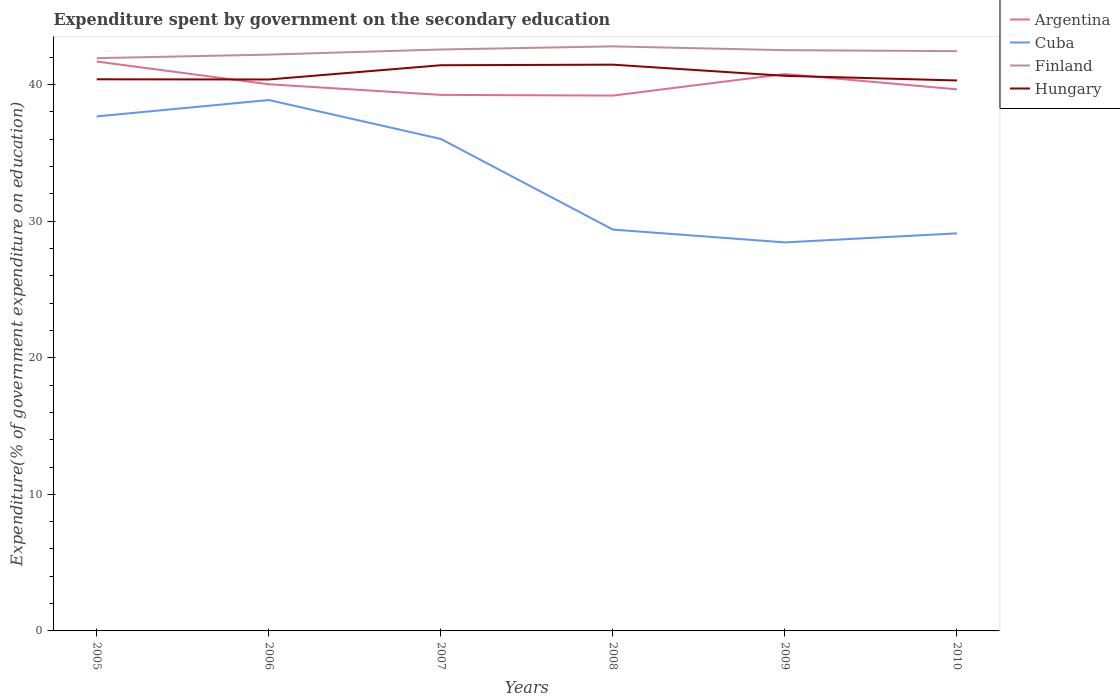Does the line corresponding to Hungary intersect with the line corresponding to Argentina?
Your answer should be very brief. Yes. Across all years, what is the maximum expenditure spent by government on the secondary education in Argentina?
Keep it short and to the point. 39.19. In which year was the expenditure spent by government on the secondary education in Cuba maximum?
Provide a short and direct response. 2009. What is the total expenditure spent by government on the secondary education in Argentina in the graph?
Keep it short and to the point. 0.78. What is the difference between the highest and the second highest expenditure spent by government on the secondary education in Finland?
Keep it short and to the point. 0.86. How many lines are there?
Your response must be concise. 4. What is the difference between two consecutive major ticks on the Y-axis?
Your response must be concise. 10. Where does the legend appear in the graph?
Offer a very short reply. Top right. How are the legend labels stacked?
Offer a terse response. Vertical. What is the title of the graph?
Your answer should be very brief. Expenditure spent by government on the secondary education. Does "Eritrea" appear as one of the legend labels in the graph?
Your answer should be very brief. No. What is the label or title of the X-axis?
Your answer should be compact. Years. What is the label or title of the Y-axis?
Ensure brevity in your answer.  Expenditure(% of government expenditure on education). What is the Expenditure(% of government expenditure on education) in Argentina in 2005?
Your response must be concise. 41.69. What is the Expenditure(% of government expenditure on education) in Cuba in 2005?
Make the answer very short. 37.67. What is the Expenditure(% of government expenditure on education) in Finland in 2005?
Ensure brevity in your answer.  41.93. What is the Expenditure(% of government expenditure on education) in Hungary in 2005?
Provide a succinct answer. 40.39. What is the Expenditure(% of government expenditure on education) of Argentina in 2006?
Your response must be concise. 40.02. What is the Expenditure(% of government expenditure on education) in Cuba in 2006?
Provide a succinct answer. 38.87. What is the Expenditure(% of government expenditure on education) in Finland in 2006?
Offer a very short reply. 42.19. What is the Expenditure(% of government expenditure on education) in Hungary in 2006?
Give a very brief answer. 40.37. What is the Expenditure(% of government expenditure on education) of Argentina in 2007?
Your response must be concise. 39.25. What is the Expenditure(% of government expenditure on education) of Cuba in 2007?
Provide a short and direct response. 36.02. What is the Expenditure(% of government expenditure on education) of Finland in 2007?
Keep it short and to the point. 42.57. What is the Expenditure(% of government expenditure on education) of Hungary in 2007?
Provide a succinct answer. 41.42. What is the Expenditure(% of government expenditure on education) of Argentina in 2008?
Make the answer very short. 39.19. What is the Expenditure(% of government expenditure on education) of Cuba in 2008?
Your answer should be compact. 29.38. What is the Expenditure(% of government expenditure on education) in Finland in 2008?
Your response must be concise. 42.8. What is the Expenditure(% of government expenditure on education) of Hungary in 2008?
Give a very brief answer. 41.46. What is the Expenditure(% of government expenditure on education) in Argentina in 2009?
Ensure brevity in your answer.  40.77. What is the Expenditure(% of government expenditure on education) in Cuba in 2009?
Offer a terse response. 28.44. What is the Expenditure(% of government expenditure on education) of Finland in 2009?
Offer a very short reply. 42.52. What is the Expenditure(% of government expenditure on education) of Hungary in 2009?
Your response must be concise. 40.64. What is the Expenditure(% of government expenditure on education) of Argentina in 2010?
Give a very brief answer. 39.65. What is the Expenditure(% of government expenditure on education) in Cuba in 2010?
Your answer should be very brief. 29.11. What is the Expenditure(% of government expenditure on education) of Finland in 2010?
Keep it short and to the point. 42.45. What is the Expenditure(% of government expenditure on education) in Hungary in 2010?
Offer a very short reply. 40.3. Across all years, what is the maximum Expenditure(% of government expenditure on education) of Argentina?
Your response must be concise. 41.69. Across all years, what is the maximum Expenditure(% of government expenditure on education) of Cuba?
Make the answer very short. 38.87. Across all years, what is the maximum Expenditure(% of government expenditure on education) of Finland?
Provide a short and direct response. 42.8. Across all years, what is the maximum Expenditure(% of government expenditure on education) in Hungary?
Give a very brief answer. 41.46. Across all years, what is the minimum Expenditure(% of government expenditure on education) of Argentina?
Offer a very short reply. 39.19. Across all years, what is the minimum Expenditure(% of government expenditure on education) in Cuba?
Provide a succinct answer. 28.44. Across all years, what is the minimum Expenditure(% of government expenditure on education) in Finland?
Make the answer very short. 41.93. Across all years, what is the minimum Expenditure(% of government expenditure on education) of Hungary?
Ensure brevity in your answer.  40.3. What is the total Expenditure(% of government expenditure on education) in Argentina in the graph?
Give a very brief answer. 240.57. What is the total Expenditure(% of government expenditure on education) of Cuba in the graph?
Provide a short and direct response. 199.49. What is the total Expenditure(% of government expenditure on education) of Finland in the graph?
Give a very brief answer. 254.46. What is the total Expenditure(% of government expenditure on education) of Hungary in the graph?
Make the answer very short. 244.57. What is the difference between the Expenditure(% of government expenditure on education) of Argentina in 2005 and that in 2006?
Ensure brevity in your answer.  1.67. What is the difference between the Expenditure(% of government expenditure on education) of Finland in 2005 and that in 2006?
Offer a terse response. -0.26. What is the difference between the Expenditure(% of government expenditure on education) in Hungary in 2005 and that in 2006?
Give a very brief answer. 0.01. What is the difference between the Expenditure(% of government expenditure on education) in Argentina in 2005 and that in 2007?
Offer a very short reply. 2.44. What is the difference between the Expenditure(% of government expenditure on education) of Cuba in 2005 and that in 2007?
Ensure brevity in your answer.  1.65. What is the difference between the Expenditure(% of government expenditure on education) in Finland in 2005 and that in 2007?
Give a very brief answer. -0.63. What is the difference between the Expenditure(% of government expenditure on education) in Hungary in 2005 and that in 2007?
Make the answer very short. -1.03. What is the difference between the Expenditure(% of government expenditure on education) of Argentina in 2005 and that in 2008?
Offer a terse response. 2.49. What is the difference between the Expenditure(% of government expenditure on education) of Cuba in 2005 and that in 2008?
Ensure brevity in your answer.  8.28. What is the difference between the Expenditure(% of government expenditure on education) of Finland in 2005 and that in 2008?
Your response must be concise. -0.86. What is the difference between the Expenditure(% of government expenditure on education) in Hungary in 2005 and that in 2008?
Keep it short and to the point. -1.07. What is the difference between the Expenditure(% of government expenditure on education) of Argentina in 2005 and that in 2009?
Provide a short and direct response. 0.91. What is the difference between the Expenditure(% of government expenditure on education) in Cuba in 2005 and that in 2009?
Make the answer very short. 9.22. What is the difference between the Expenditure(% of government expenditure on education) in Finland in 2005 and that in 2009?
Provide a succinct answer. -0.58. What is the difference between the Expenditure(% of government expenditure on education) of Hungary in 2005 and that in 2009?
Keep it short and to the point. -0.25. What is the difference between the Expenditure(% of government expenditure on education) in Argentina in 2005 and that in 2010?
Your answer should be very brief. 2.04. What is the difference between the Expenditure(% of government expenditure on education) of Cuba in 2005 and that in 2010?
Offer a terse response. 8.56. What is the difference between the Expenditure(% of government expenditure on education) in Finland in 2005 and that in 2010?
Keep it short and to the point. -0.51. What is the difference between the Expenditure(% of government expenditure on education) in Hungary in 2005 and that in 2010?
Ensure brevity in your answer.  0.09. What is the difference between the Expenditure(% of government expenditure on education) in Argentina in 2006 and that in 2007?
Give a very brief answer. 0.78. What is the difference between the Expenditure(% of government expenditure on education) of Cuba in 2006 and that in 2007?
Offer a very short reply. 2.85. What is the difference between the Expenditure(% of government expenditure on education) in Finland in 2006 and that in 2007?
Your response must be concise. -0.38. What is the difference between the Expenditure(% of government expenditure on education) in Hungary in 2006 and that in 2007?
Your answer should be very brief. -1.04. What is the difference between the Expenditure(% of government expenditure on education) in Argentina in 2006 and that in 2008?
Ensure brevity in your answer.  0.83. What is the difference between the Expenditure(% of government expenditure on education) in Cuba in 2006 and that in 2008?
Provide a short and direct response. 9.48. What is the difference between the Expenditure(% of government expenditure on education) in Finland in 2006 and that in 2008?
Ensure brevity in your answer.  -0.6. What is the difference between the Expenditure(% of government expenditure on education) of Hungary in 2006 and that in 2008?
Ensure brevity in your answer.  -1.08. What is the difference between the Expenditure(% of government expenditure on education) of Argentina in 2006 and that in 2009?
Give a very brief answer. -0.75. What is the difference between the Expenditure(% of government expenditure on education) of Cuba in 2006 and that in 2009?
Provide a succinct answer. 10.42. What is the difference between the Expenditure(% of government expenditure on education) of Finland in 2006 and that in 2009?
Your answer should be very brief. -0.32. What is the difference between the Expenditure(% of government expenditure on education) of Hungary in 2006 and that in 2009?
Keep it short and to the point. -0.27. What is the difference between the Expenditure(% of government expenditure on education) of Argentina in 2006 and that in 2010?
Offer a very short reply. 0.37. What is the difference between the Expenditure(% of government expenditure on education) in Cuba in 2006 and that in 2010?
Make the answer very short. 9.76. What is the difference between the Expenditure(% of government expenditure on education) of Finland in 2006 and that in 2010?
Your answer should be compact. -0.25. What is the difference between the Expenditure(% of government expenditure on education) of Hungary in 2006 and that in 2010?
Your response must be concise. 0.07. What is the difference between the Expenditure(% of government expenditure on education) in Argentina in 2007 and that in 2008?
Give a very brief answer. 0.05. What is the difference between the Expenditure(% of government expenditure on education) of Cuba in 2007 and that in 2008?
Provide a short and direct response. 6.64. What is the difference between the Expenditure(% of government expenditure on education) in Finland in 2007 and that in 2008?
Make the answer very short. -0.23. What is the difference between the Expenditure(% of government expenditure on education) of Hungary in 2007 and that in 2008?
Make the answer very short. -0.04. What is the difference between the Expenditure(% of government expenditure on education) of Argentina in 2007 and that in 2009?
Provide a succinct answer. -1.53. What is the difference between the Expenditure(% of government expenditure on education) of Cuba in 2007 and that in 2009?
Keep it short and to the point. 7.57. What is the difference between the Expenditure(% of government expenditure on education) in Finland in 2007 and that in 2009?
Give a very brief answer. 0.05. What is the difference between the Expenditure(% of government expenditure on education) in Hungary in 2007 and that in 2009?
Your answer should be compact. 0.78. What is the difference between the Expenditure(% of government expenditure on education) in Argentina in 2007 and that in 2010?
Give a very brief answer. -0.4. What is the difference between the Expenditure(% of government expenditure on education) of Cuba in 2007 and that in 2010?
Make the answer very short. 6.91. What is the difference between the Expenditure(% of government expenditure on education) of Finland in 2007 and that in 2010?
Offer a terse response. 0.12. What is the difference between the Expenditure(% of government expenditure on education) in Hungary in 2007 and that in 2010?
Give a very brief answer. 1.11. What is the difference between the Expenditure(% of government expenditure on education) of Argentina in 2008 and that in 2009?
Offer a terse response. -1.58. What is the difference between the Expenditure(% of government expenditure on education) in Cuba in 2008 and that in 2009?
Your response must be concise. 0.94. What is the difference between the Expenditure(% of government expenditure on education) in Finland in 2008 and that in 2009?
Give a very brief answer. 0.28. What is the difference between the Expenditure(% of government expenditure on education) in Hungary in 2008 and that in 2009?
Your answer should be very brief. 0.82. What is the difference between the Expenditure(% of government expenditure on education) of Argentina in 2008 and that in 2010?
Provide a succinct answer. -0.46. What is the difference between the Expenditure(% of government expenditure on education) in Cuba in 2008 and that in 2010?
Offer a terse response. 0.28. What is the difference between the Expenditure(% of government expenditure on education) in Finland in 2008 and that in 2010?
Give a very brief answer. 0.35. What is the difference between the Expenditure(% of government expenditure on education) of Hungary in 2008 and that in 2010?
Provide a succinct answer. 1.16. What is the difference between the Expenditure(% of government expenditure on education) in Argentina in 2009 and that in 2010?
Provide a short and direct response. 1.12. What is the difference between the Expenditure(% of government expenditure on education) of Cuba in 2009 and that in 2010?
Your response must be concise. -0.66. What is the difference between the Expenditure(% of government expenditure on education) in Finland in 2009 and that in 2010?
Your answer should be very brief. 0.07. What is the difference between the Expenditure(% of government expenditure on education) of Hungary in 2009 and that in 2010?
Give a very brief answer. 0.34. What is the difference between the Expenditure(% of government expenditure on education) of Argentina in 2005 and the Expenditure(% of government expenditure on education) of Cuba in 2006?
Provide a short and direct response. 2.82. What is the difference between the Expenditure(% of government expenditure on education) in Argentina in 2005 and the Expenditure(% of government expenditure on education) in Finland in 2006?
Offer a terse response. -0.51. What is the difference between the Expenditure(% of government expenditure on education) of Argentina in 2005 and the Expenditure(% of government expenditure on education) of Hungary in 2006?
Offer a terse response. 1.31. What is the difference between the Expenditure(% of government expenditure on education) in Cuba in 2005 and the Expenditure(% of government expenditure on education) in Finland in 2006?
Make the answer very short. -4.53. What is the difference between the Expenditure(% of government expenditure on education) in Cuba in 2005 and the Expenditure(% of government expenditure on education) in Hungary in 2006?
Ensure brevity in your answer.  -2.7. What is the difference between the Expenditure(% of government expenditure on education) of Finland in 2005 and the Expenditure(% of government expenditure on education) of Hungary in 2006?
Your answer should be compact. 1.56. What is the difference between the Expenditure(% of government expenditure on education) of Argentina in 2005 and the Expenditure(% of government expenditure on education) of Cuba in 2007?
Your answer should be very brief. 5.67. What is the difference between the Expenditure(% of government expenditure on education) in Argentina in 2005 and the Expenditure(% of government expenditure on education) in Finland in 2007?
Make the answer very short. -0.88. What is the difference between the Expenditure(% of government expenditure on education) in Argentina in 2005 and the Expenditure(% of government expenditure on education) in Hungary in 2007?
Your answer should be compact. 0.27. What is the difference between the Expenditure(% of government expenditure on education) in Cuba in 2005 and the Expenditure(% of government expenditure on education) in Finland in 2007?
Your answer should be compact. -4.9. What is the difference between the Expenditure(% of government expenditure on education) in Cuba in 2005 and the Expenditure(% of government expenditure on education) in Hungary in 2007?
Ensure brevity in your answer.  -3.75. What is the difference between the Expenditure(% of government expenditure on education) in Finland in 2005 and the Expenditure(% of government expenditure on education) in Hungary in 2007?
Make the answer very short. 0.52. What is the difference between the Expenditure(% of government expenditure on education) in Argentina in 2005 and the Expenditure(% of government expenditure on education) in Cuba in 2008?
Your answer should be compact. 12.3. What is the difference between the Expenditure(% of government expenditure on education) in Argentina in 2005 and the Expenditure(% of government expenditure on education) in Finland in 2008?
Make the answer very short. -1.11. What is the difference between the Expenditure(% of government expenditure on education) of Argentina in 2005 and the Expenditure(% of government expenditure on education) of Hungary in 2008?
Keep it short and to the point. 0.23. What is the difference between the Expenditure(% of government expenditure on education) of Cuba in 2005 and the Expenditure(% of government expenditure on education) of Finland in 2008?
Offer a very short reply. -5.13. What is the difference between the Expenditure(% of government expenditure on education) of Cuba in 2005 and the Expenditure(% of government expenditure on education) of Hungary in 2008?
Offer a terse response. -3.79. What is the difference between the Expenditure(% of government expenditure on education) of Finland in 2005 and the Expenditure(% of government expenditure on education) of Hungary in 2008?
Your answer should be very brief. 0.48. What is the difference between the Expenditure(% of government expenditure on education) of Argentina in 2005 and the Expenditure(% of government expenditure on education) of Cuba in 2009?
Provide a succinct answer. 13.24. What is the difference between the Expenditure(% of government expenditure on education) of Argentina in 2005 and the Expenditure(% of government expenditure on education) of Finland in 2009?
Keep it short and to the point. -0.83. What is the difference between the Expenditure(% of government expenditure on education) in Argentina in 2005 and the Expenditure(% of government expenditure on education) in Hungary in 2009?
Your answer should be very brief. 1.05. What is the difference between the Expenditure(% of government expenditure on education) of Cuba in 2005 and the Expenditure(% of government expenditure on education) of Finland in 2009?
Ensure brevity in your answer.  -4.85. What is the difference between the Expenditure(% of government expenditure on education) of Cuba in 2005 and the Expenditure(% of government expenditure on education) of Hungary in 2009?
Make the answer very short. -2.97. What is the difference between the Expenditure(% of government expenditure on education) of Finland in 2005 and the Expenditure(% of government expenditure on education) of Hungary in 2009?
Offer a terse response. 1.29. What is the difference between the Expenditure(% of government expenditure on education) in Argentina in 2005 and the Expenditure(% of government expenditure on education) in Cuba in 2010?
Offer a very short reply. 12.58. What is the difference between the Expenditure(% of government expenditure on education) in Argentina in 2005 and the Expenditure(% of government expenditure on education) in Finland in 2010?
Your answer should be compact. -0.76. What is the difference between the Expenditure(% of government expenditure on education) of Argentina in 2005 and the Expenditure(% of government expenditure on education) of Hungary in 2010?
Your answer should be compact. 1.39. What is the difference between the Expenditure(% of government expenditure on education) of Cuba in 2005 and the Expenditure(% of government expenditure on education) of Finland in 2010?
Provide a short and direct response. -4.78. What is the difference between the Expenditure(% of government expenditure on education) of Cuba in 2005 and the Expenditure(% of government expenditure on education) of Hungary in 2010?
Your answer should be compact. -2.63. What is the difference between the Expenditure(% of government expenditure on education) in Finland in 2005 and the Expenditure(% of government expenditure on education) in Hungary in 2010?
Provide a succinct answer. 1.63. What is the difference between the Expenditure(% of government expenditure on education) of Argentina in 2006 and the Expenditure(% of government expenditure on education) of Cuba in 2007?
Ensure brevity in your answer.  4. What is the difference between the Expenditure(% of government expenditure on education) in Argentina in 2006 and the Expenditure(% of government expenditure on education) in Finland in 2007?
Make the answer very short. -2.55. What is the difference between the Expenditure(% of government expenditure on education) of Argentina in 2006 and the Expenditure(% of government expenditure on education) of Hungary in 2007?
Ensure brevity in your answer.  -1.39. What is the difference between the Expenditure(% of government expenditure on education) of Cuba in 2006 and the Expenditure(% of government expenditure on education) of Finland in 2007?
Make the answer very short. -3.7. What is the difference between the Expenditure(% of government expenditure on education) of Cuba in 2006 and the Expenditure(% of government expenditure on education) of Hungary in 2007?
Ensure brevity in your answer.  -2.55. What is the difference between the Expenditure(% of government expenditure on education) in Finland in 2006 and the Expenditure(% of government expenditure on education) in Hungary in 2007?
Keep it short and to the point. 0.78. What is the difference between the Expenditure(% of government expenditure on education) of Argentina in 2006 and the Expenditure(% of government expenditure on education) of Cuba in 2008?
Give a very brief answer. 10.64. What is the difference between the Expenditure(% of government expenditure on education) in Argentina in 2006 and the Expenditure(% of government expenditure on education) in Finland in 2008?
Offer a terse response. -2.78. What is the difference between the Expenditure(% of government expenditure on education) in Argentina in 2006 and the Expenditure(% of government expenditure on education) in Hungary in 2008?
Keep it short and to the point. -1.44. What is the difference between the Expenditure(% of government expenditure on education) in Cuba in 2006 and the Expenditure(% of government expenditure on education) in Finland in 2008?
Offer a very short reply. -3.93. What is the difference between the Expenditure(% of government expenditure on education) of Cuba in 2006 and the Expenditure(% of government expenditure on education) of Hungary in 2008?
Give a very brief answer. -2.59. What is the difference between the Expenditure(% of government expenditure on education) in Finland in 2006 and the Expenditure(% of government expenditure on education) in Hungary in 2008?
Give a very brief answer. 0.74. What is the difference between the Expenditure(% of government expenditure on education) in Argentina in 2006 and the Expenditure(% of government expenditure on education) in Cuba in 2009?
Make the answer very short. 11.58. What is the difference between the Expenditure(% of government expenditure on education) in Argentina in 2006 and the Expenditure(% of government expenditure on education) in Finland in 2009?
Provide a short and direct response. -2.5. What is the difference between the Expenditure(% of government expenditure on education) in Argentina in 2006 and the Expenditure(% of government expenditure on education) in Hungary in 2009?
Keep it short and to the point. -0.62. What is the difference between the Expenditure(% of government expenditure on education) in Cuba in 2006 and the Expenditure(% of government expenditure on education) in Finland in 2009?
Offer a terse response. -3.65. What is the difference between the Expenditure(% of government expenditure on education) of Cuba in 2006 and the Expenditure(% of government expenditure on education) of Hungary in 2009?
Offer a terse response. -1.77. What is the difference between the Expenditure(% of government expenditure on education) of Finland in 2006 and the Expenditure(% of government expenditure on education) of Hungary in 2009?
Your response must be concise. 1.55. What is the difference between the Expenditure(% of government expenditure on education) of Argentina in 2006 and the Expenditure(% of government expenditure on education) of Cuba in 2010?
Keep it short and to the point. 10.91. What is the difference between the Expenditure(% of government expenditure on education) of Argentina in 2006 and the Expenditure(% of government expenditure on education) of Finland in 2010?
Keep it short and to the point. -2.43. What is the difference between the Expenditure(% of government expenditure on education) of Argentina in 2006 and the Expenditure(% of government expenditure on education) of Hungary in 2010?
Your answer should be compact. -0.28. What is the difference between the Expenditure(% of government expenditure on education) of Cuba in 2006 and the Expenditure(% of government expenditure on education) of Finland in 2010?
Keep it short and to the point. -3.58. What is the difference between the Expenditure(% of government expenditure on education) in Cuba in 2006 and the Expenditure(% of government expenditure on education) in Hungary in 2010?
Provide a short and direct response. -1.43. What is the difference between the Expenditure(% of government expenditure on education) in Finland in 2006 and the Expenditure(% of government expenditure on education) in Hungary in 2010?
Ensure brevity in your answer.  1.89. What is the difference between the Expenditure(% of government expenditure on education) of Argentina in 2007 and the Expenditure(% of government expenditure on education) of Cuba in 2008?
Your answer should be compact. 9.86. What is the difference between the Expenditure(% of government expenditure on education) in Argentina in 2007 and the Expenditure(% of government expenditure on education) in Finland in 2008?
Provide a short and direct response. -3.55. What is the difference between the Expenditure(% of government expenditure on education) of Argentina in 2007 and the Expenditure(% of government expenditure on education) of Hungary in 2008?
Offer a very short reply. -2.21. What is the difference between the Expenditure(% of government expenditure on education) of Cuba in 2007 and the Expenditure(% of government expenditure on education) of Finland in 2008?
Keep it short and to the point. -6.78. What is the difference between the Expenditure(% of government expenditure on education) in Cuba in 2007 and the Expenditure(% of government expenditure on education) in Hungary in 2008?
Provide a succinct answer. -5.44. What is the difference between the Expenditure(% of government expenditure on education) of Finland in 2007 and the Expenditure(% of government expenditure on education) of Hungary in 2008?
Offer a terse response. 1.11. What is the difference between the Expenditure(% of government expenditure on education) in Argentina in 2007 and the Expenditure(% of government expenditure on education) in Cuba in 2009?
Give a very brief answer. 10.8. What is the difference between the Expenditure(% of government expenditure on education) in Argentina in 2007 and the Expenditure(% of government expenditure on education) in Finland in 2009?
Your answer should be compact. -3.27. What is the difference between the Expenditure(% of government expenditure on education) of Argentina in 2007 and the Expenditure(% of government expenditure on education) of Hungary in 2009?
Your answer should be very brief. -1.39. What is the difference between the Expenditure(% of government expenditure on education) in Cuba in 2007 and the Expenditure(% of government expenditure on education) in Finland in 2009?
Make the answer very short. -6.5. What is the difference between the Expenditure(% of government expenditure on education) in Cuba in 2007 and the Expenditure(% of government expenditure on education) in Hungary in 2009?
Keep it short and to the point. -4.62. What is the difference between the Expenditure(% of government expenditure on education) of Finland in 2007 and the Expenditure(% of government expenditure on education) of Hungary in 2009?
Ensure brevity in your answer.  1.93. What is the difference between the Expenditure(% of government expenditure on education) in Argentina in 2007 and the Expenditure(% of government expenditure on education) in Cuba in 2010?
Ensure brevity in your answer.  10.14. What is the difference between the Expenditure(% of government expenditure on education) of Argentina in 2007 and the Expenditure(% of government expenditure on education) of Finland in 2010?
Make the answer very short. -3.2. What is the difference between the Expenditure(% of government expenditure on education) of Argentina in 2007 and the Expenditure(% of government expenditure on education) of Hungary in 2010?
Offer a terse response. -1.05. What is the difference between the Expenditure(% of government expenditure on education) of Cuba in 2007 and the Expenditure(% of government expenditure on education) of Finland in 2010?
Offer a terse response. -6.43. What is the difference between the Expenditure(% of government expenditure on education) in Cuba in 2007 and the Expenditure(% of government expenditure on education) in Hungary in 2010?
Make the answer very short. -4.28. What is the difference between the Expenditure(% of government expenditure on education) in Finland in 2007 and the Expenditure(% of government expenditure on education) in Hungary in 2010?
Provide a short and direct response. 2.27. What is the difference between the Expenditure(% of government expenditure on education) in Argentina in 2008 and the Expenditure(% of government expenditure on education) in Cuba in 2009?
Make the answer very short. 10.75. What is the difference between the Expenditure(% of government expenditure on education) in Argentina in 2008 and the Expenditure(% of government expenditure on education) in Finland in 2009?
Keep it short and to the point. -3.32. What is the difference between the Expenditure(% of government expenditure on education) of Argentina in 2008 and the Expenditure(% of government expenditure on education) of Hungary in 2009?
Offer a terse response. -1.45. What is the difference between the Expenditure(% of government expenditure on education) of Cuba in 2008 and the Expenditure(% of government expenditure on education) of Finland in 2009?
Make the answer very short. -13.13. What is the difference between the Expenditure(% of government expenditure on education) of Cuba in 2008 and the Expenditure(% of government expenditure on education) of Hungary in 2009?
Your answer should be compact. -11.26. What is the difference between the Expenditure(% of government expenditure on education) in Finland in 2008 and the Expenditure(% of government expenditure on education) in Hungary in 2009?
Offer a very short reply. 2.16. What is the difference between the Expenditure(% of government expenditure on education) of Argentina in 2008 and the Expenditure(% of government expenditure on education) of Cuba in 2010?
Offer a very short reply. 10.09. What is the difference between the Expenditure(% of government expenditure on education) in Argentina in 2008 and the Expenditure(% of government expenditure on education) in Finland in 2010?
Provide a succinct answer. -3.25. What is the difference between the Expenditure(% of government expenditure on education) of Argentina in 2008 and the Expenditure(% of government expenditure on education) of Hungary in 2010?
Your answer should be very brief. -1.11. What is the difference between the Expenditure(% of government expenditure on education) of Cuba in 2008 and the Expenditure(% of government expenditure on education) of Finland in 2010?
Make the answer very short. -13.06. What is the difference between the Expenditure(% of government expenditure on education) of Cuba in 2008 and the Expenditure(% of government expenditure on education) of Hungary in 2010?
Offer a very short reply. -10.92. What is the difference between the Expenditure(% of government expenditure on education) in Finland in 2008 and the Expenditure(% of government expenditure on education) in Hungary in 2010?
Provide a short and direct response. 2.5. What is the difference between the Expenditure(% of government expenditure on education) of Argentina in 2009 and the Expenditure(% of government expenditure on education) of Cuba in 2010?
Your answer should be very brief. 11.67. What is the difference between the Expenditure(% of government expenditure on education) in Argentina in 2009 and the Expenditure(% of government expenditure on education) in Finland in 2010?
Make the answer very short. -1.67. What is the difference between the Expenditure(% of government expenditure on education) of Argentina in 2009 and the Expenditure(% of government expenditure on education) of Hungary in 2010?
Your response must be concise. 0.47. What is the difference between the Expenditure(% of government expenditure on education) in Cuba in 2009 and the Expenditure(% of government expenditure on education) in Finland in 2010?
Provide a succinct answer. -14. What is the difference between the Expenditure(% of government expenditure on education) in Cuba in 2009 and the Expenditure(% of government expenditure on education) in Hungary in 2010?
Your answer should be very brief. -11.86. What is the difference between the Expenditure(% of government expenditure on education) in Finland in 2009 and the Expenditure(% of government expenditure on education) in Hungary in 2010?
Provide a short and direct response. 2.22. What is the average Expenditure(% of government expenditure on education) in Argentina per year?
Offer a terse response. 40.1. What is the average Expenditure(% of government expenditure on education) of Cuba per year?
Offer a very short reply. 33.25. What is the average Expenditure(% of government expenditure on education) in Finland per year?
Make the answer very short. 42.41. What is the average Expenditure(% of government expenditure on education) of Hungary per year?
Offer a very short reply. 40.76. In the year 2005, what is the difference between the Expenditure(% of government expenditure on education) in Argentina and Expenditure(% of government expenditure on education) in Cuba?
Offer a very short reply. 4.02. In the year 2005, what is the difference between the Expenditure(% of government expenditure on education) of Argentina and Expenditure(% of government expenditure on education) of Finland?
Offer a very short reply. -0.25. In the year 2005, what is the difference between the Expenditure(% of government expenditure on education) of Argentina and Expenditure(% of government expenditure on education) of Hungary?
Your answer should be compact. 1.3. In the year 2005, what is the difference between the Expenditure(% of government expenditure on education) of Cuba and Expenditure(% of government expenditure on education) of Finland?
Offer a very short reply. -4.27. In the year 2005, what is the difference between the Expenditure(% of government expenditure on education) of Cuba and Expenditure(% of government expenditure on education) of Hungary?
Make the answer very short. -2.72. In the year 2005, what is the difference between the Expenditure(% of government expenditure on education) in Finland and Expenditure(% of government expenditure on education) in Hungary?
Ensure brevity in your answer.  1.55. In the year 2006, what is the difference between the Expenditure(% of government expenditure on education) in Argentina and Expenditure(% of government expenditure on education) in Cuba?
Give a very brief answer. 1.15. In the year 2006, what is the difference between the Expenditure(% of government expenditure on education) of Argentina and Expenditure(% of government expenditure on education) of Finland?
Offer a terse response. -2.17. In the year 2006, what is the difference between the Expenditure(% of government expenditure on education) in Argentina and Expenditure(% of government expenditure on education) in Hungary?
Ensure brevity in your answer.  -0.35. In the year 2006, what is the difference between the Expenditure(% of government expenditure on education) of Cuba and Expenditure(% of government expenditure on education) of Finland?
Keep it short and to the point. -3.33. In the year 2006, what is the difference between the Expenditure(% of government expenditure on education) in Cuba and Expenditure(% of government expenditure on education) in Hungary?
Your response must be concise. -1.5. In the year 2006, what is the difference between the Expenditure(% of government expenditure on education) of Finland and Expenditure(% of government expenditure on education) of Hungary?
Make the answer very short. 1.82. In the year 2007, what is the difference between the Expenditure(% of government expenditure on education) of Argentina and Expenditure(% of government expenditure on education) of Cuba?
Provide a succinct answer. 3.23. In the year 2007, what is the difference between the Expenditure(% of government expenditure on education) of Argentina and Expenditure(% of government expenditure on education) of Finland?
Your answer should be very brief. -3.32. In the year 2007, what is the difference between the Expenditure(% of government expenditure on education) in Argentina and Expenditure(% of government expenditure on education) in Hungary?
Provide a short and direct response. -2.17. In the year 2007, what is the difference between the Expenditure(% of government expenditure on education) in Cuba and Expenditure(% of government expenditure on education) in Finland?
Provide a succinct answer. -6.55. In the year 2007, what is the difference between the Expenditure(% of government expenditure on education) of Cuba and Expenditure(% of government expenditure on education) of Hungary?
Keep it short and to the point. -5.4. In the year 2007, what is the difference between the Expenditure(% of government expenditure on education) of Finland and Expenditure(% of government expenditure on education) of Hungary?
Provide a succinct answer. 1.15. In the year 2008, what is the difference between the Expenditure(% of government expenditure on education) in Argentina and Expenditure(% of government expenditure on education) in Cuba?
Keep it short and to the point. 9.81. In the year 2008, what is the difference between the Expenditure(% of government expenditure on education) of Argentina and Expenditure(% of government expenditure on education) of Finland?
Keep it short and to the point. -3.6. In the year 2008, what is the difference between the Expenditure(% of government expenditure on education) in Argentina and Expenditure(% of government expenditure on education) in Hungary?
Give a very brief answer. -2.26. In the year 2008, what is the difference between the Expenditure(% of government expenditure on education) of Cuba and Expenditure(% of government expenditure on education) of Finland?
Offer a very short reply. -13.41. In the year 2008, what is the difference between the Expenditure(% of government expenditure on education) of Cuba and Expenditure(% of government expenditure on education) of Hungary?
Make the answer very short. -12.07. In the year 2008, what is the difference between the Expenditure(% of government expenditure on education) in Finland and Expenditure(% of government expenditure on education) in Hungary?
Provide a succinct answer. 1.34. In the year 2009, what is the difference between the Expenditure(% of government expenditure on education) of Argentina and Expenditure(% of government expenditure on education) of Cuba?
Provide a succinct answer. 12.33. In the year 2009, what is the difference between the Expenditure(% of government expenditure on education) in Argentina and Expenditure(% of government expenditure on education) in Finland?
Provide a succinct answer. -1.75. In the year 2009, what is the difference between the Expenditure(% of government expenditure on education) in Argentina and Expenditure(% of government expenditure on education) in Hungary?
Offer a very short reply. 0.13. In the year 2009, what is the difference between the Expenditure(% of government expenditure on education) in Cuba and Expenditure(% of government expenditure on education) in Finland?
Offer a very short reply. -14.07. In the year 2009, what is the difference between the Expenditure(% of government expenditure on education) in Cuba and Expenditure(% of government expenditure on education) in Hungary?
Keep it short and to the point. -12.2. In the year 2009, what is the difference between the Expenditure(% of government expenditure on education) of Finland and Expenditure(% of government expenditure on education) of Hungary?
Keep it short and to the point. 1.88. In the year 2010, what is the difference between the Expenditure(% of government expenditure on education) in Argentina and Expenditure(% of government expenditure on education) in Cuba?
Offer a very short reply. 10.54. In the year 2010, what is the difference between the Expenditure(% of government expenditure on education) in Argentina and Expenditure(% of government expenditure on education) in Finland?
Ensure brevity in your answer.  -2.8. In the year 2010, what is the difference between the Expenditure(% of government expenditure on education) of Argentina and Expenditure(% of government expenditure on education) of Hungary?
Offer a terse response. -0.65. In the year 2010, what is the difference between the Expenditure(% of government expenditure on education) of Cuba and Expenditure(% of government expenditure on education) of Finland?
Make the answer very short. -13.34. In the year 2010, what is the difference between the Expenditure(% of government expenditure on education) in Cuba and Expenditure(% of government expenditure on education) in Hungary?
Offer a very short reply. -11.19. In the year 2010, what is the difference between the Expenditure(% of government expenditure on education) of Finland and Expenditure(% of government expenditure on education) of Hungary?
Keep it short and to the point. 2.15. What is the ratio of the Expenditure(% of government expenditure on education) of Argentina in 2005 to that in 2006?
Your answer should be compact. 1.04. What is the ratio of the Expenditure(% of government expenditure on education) in Cuba in 2005 to that in 2006?
Give a very brief answer. 0.97. What is the ratio of the Expenditure(% of government expenditure on education) in Argentina in 2005 to that in 2007?
Ensure brevity in your answer.  1.06. What is the ratio of the Expenditure(% of government expenditure on education) in Cuba in 2005 to that in 2007?
Offer a very short reply. 1.05. What is the ratio of the Expenditure(% of government expenditure on education) of Finland in 2005 to that in 2007?
Your answer should be very brief. 0.99. What is the ratio of the Expenditure(% of government expenditure on education) in Hungary in 2005 to that in 2007?
Provide a short and direct response. 0.98. What is the ratio of the Expenditure(% of government expenditure on education) of Argentina in 2005 to that in 2008?
Offer a terse response. 1.06. What is the ratio of the Expenditure(% of government expenditure on education) in Cuba in 2005 to that in 2008?
Your answer should be compact. 1.28. What is the ratio of the Expenditure(% of government expenditure on education) in Finland in 2005 to that in 2008?
Make the answer very short. 0.98. What is the ratio of the Expenditure(% of government expenditure on education) in Hungary in 2005 to that in 2008?
Keep it short and to the point. 0.97. What is the ratio of the Expenditure(% of government expenditure on education) of Argentina in 2005 to that in 2009?
Your answer should be compact. 1.02. What is the ratio of the Expenditure(% of government expenditure on education) of Cuba in 2005 to that in 2009?
Keep it short and to the point. 1.32. What is the ratio of the Expenditure(% of government expenditure on education) of Finland in 2005 to that in 2009?
Offer a terse response. 0.99. What is the ratio of the Expenditure(% of government expenditure on education) of Hungary in 2005 to that in 2009?
Offer a terse response. 0.99. What is the ratio of the Expenditure(% of government expenditure on education) of Argentina in 2005 to that in 2010?
Your answer should be very brief. 1.05. What is the ratio of the Expenditure(% of government expenditure on education) of Cuba in 2005 to that in 2010?
Offer a very short reply. 1.29. What is the ratio of the Expenditure(% of government expenditure on education) of Finland in 2005 to that in 2010?
Your answer should be compact. 0.99. What is the ratio of the Expenditure(% of government expenditure on education) of Hungary in 2005 to that in 2010?
Offer a very short reply. 1. What is the ratio of the Expenditure(% of government expenditure on education) in Argentina in 2006 to that in 2007?
Provide a succinct answer. 1.02. What is the ratio of the Expenditure(% of government expenditure on education) in Cuba in 2006 to that in 2007?
Your answer should be compact. 1.08. What is the ratio of the Expenditure(% of government expenditure on education) of Hungary in 2006 to that in 2007?
Provide a short and direct response. 0.97. What is the ratio of the Expenditure(% of government expenditure on education) of Argentina in 2006 to that in 2008?
Give a very brief answer. 1.02. What is the ratio of the Expenditure(% of government expenditure on education) of Cuba in 2006 to that in 2008?
Give a very brief answer. 1.32. What is the ratio of the Expenditure(% of government expenditure on education) in Finland in 2006 to that in 2008?
Provide a short and direct response. 0.99. What is the ratio of the Expenditure(% of government expenditure on education) of Hungary in 2006 to that in 2008?
Your answer should be very brief. 0.97. What is the ratio of the Expenditure(% of government expenditure on education) in Argentina in 2006 to that in 2009?
Offer a terse response. 0.98. What is the ratio of the Expenditure(% of government expenditure on education) in Cuba in 2006 to that in 2009?
Keep it short and to the point. 1.37. What is the ratio of the Expenditure(% of government expenditure on education) of Argentina in 2006 to that in 2010?
Keep it short and to the point. 1.01. What is the ratio of the Expenditure(% of government expenditure on education) in Cuba in 2006 to that in 2010?
Offer a very short reply. 1.34. What is the ratio of the Expenditure(% of government expenditure on education) in Finland in 2006 to that in 2010?
Keep it short and to the point. 0.99. What is the ratio of the Expenditure(% of government expenditure on education) in Hungary in 2006 to that in 2010?
Provide a short and direct response. 1. What is the ratio of the Expenditure(% of government expenditure on education) of Cuba in 2007 to that in 2008?
Offer a terse response. 1.23. What is the ratio of the Expenditure(% of government expenditure on education) of Finland in 2007 to that in 2008?
Your answer should be very brief. 0.99. What is the ratio of the Expenditure(% of government expenditure on education) of Hungary in 2007 to that in 2008?
Make the answer very short. 1. What is the ratio of the Expenditure(% of government expenditure on education) of Argentina in 2007 to that in 2009?
Ensure brevity in your answer.  0.96. What is the ratio of the Expenditure(% of government expenditure on education) in Cuba in 2007 to that in 2009?
Provide a short and direct response. 1.27. What is the ratio of the Expenditure(% of government expenditure on education) of Hungary in 2007 to that in 2009?
Keep it short and to the point. 1.02. What is the ratio of the Expenditure(% of government expenditure on education) of Cuba in 2007 to that in 2010?
Your response must be concise. 1.24. What is the ratio of the Expenditure(% of government expenditure on education) in Hungary in 2007 to that in 2010?
Provide a short and direct response. 1.03. What is the ratio of the Expenditure(% of government expenditure on education) in Argentina in 2008 to that in 2009?
Offer a terse response. 0.96. What is the ratio of the Expenditure(% of government expenditure on education) in Cuba in 2008 to that in 2009?
Your answer should be compact. 1.03. What is the ratio of the Expenditure(% of government expenditure on education) in Hungary in 2008 to that in 2009?
Provide a short and direct response. 1.02. What is the ratio of the Expenditure(% of government expenditure on education) of Cuba in 2008 to that in 2010?
Give a very brief answer. 1.01. What is the ratio of the Expenditure(% of government expenditure on education) in Finland in 2008 to that in 2010?
Give a very brief answer. 1.01. What is the ratio of the Expenditure(% of government expenditure on education) of Hungary in 2008 to that in 2010?
Your answer should be compact. 1.03. What is the ratio of the Expenditure(% of government expenditure on education) of Argentina in 2009 to that in 2010?
Offer a very short reply. 1.03. What is the ratio of the Expenditure(% of government expenditure on education) in Cuba in 2009 to that in 2010?
Your answer should be compact. 0.98. What is the ratio of the Expenditure(% of government expenditure on education) of Hungary in 2009 to that in 2010?
Keep it short and to the point. 1.01. What is the difference between the highest and the second highest Expenditure(% of government expenditure on education) of Argentina?
Make the answer very short. 0.91. What is the difference between the highest and the second highest Expenditure(% of government expenditure on education) in Cuba?
Provide a short and direct response. 1.2. What is the difference between the highest and the second highest Expenditure(% of government expenditure on education) of Finland?
Offer a terse response. 0.23. What is the difference between the highest and the second highest Expenditure(% of government expenditure on education) of Hungary?
Make the answer very short. 0.04. What is the difference between the highest and the lowest Expenditure(% of government expenditure on education) in Argentina?
Offer a very short reply. 2.49. What is the difference between the highest and the lowest Expenditure(% of government expenditure on education) of Cuba?
Ensure brevity in your answer.  10.42. What is the difference between the highest and the lowest Expenditure(% of government expenditure on education) of Finland?
Offer a terse response. 0.86. What is the difference between the highest and the lowest Expenditure(% of government expenditure on education) in Hungary?
Your answer should be very brief. 1.16. 